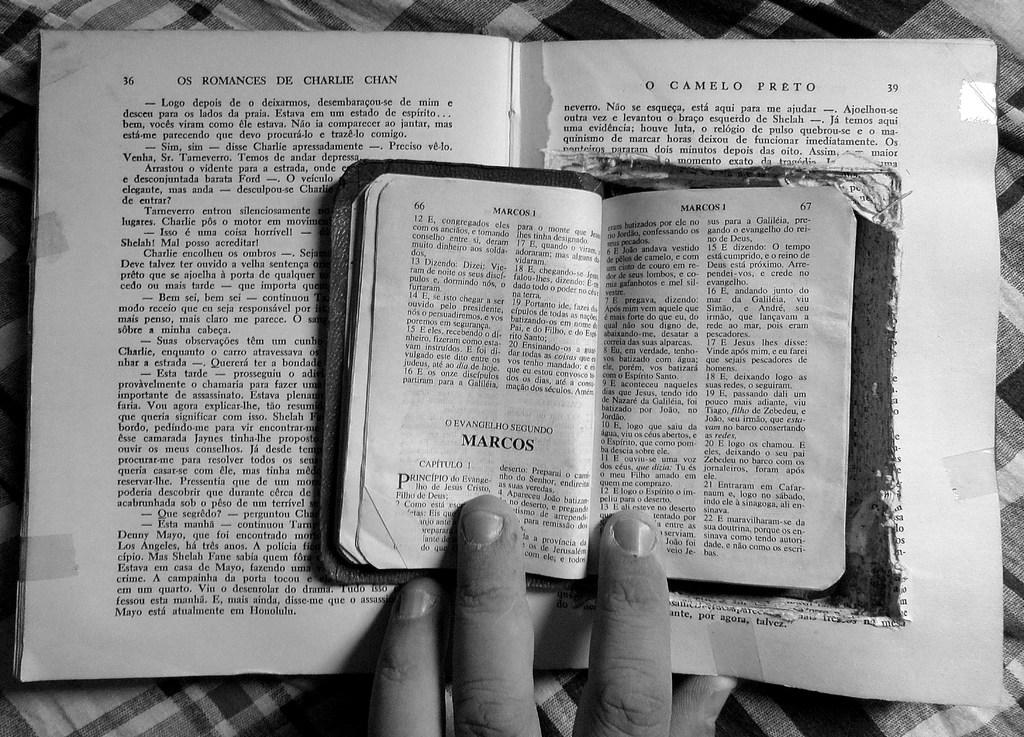<image>
Summarize the visual content of the image. A small and larger book, the small book is titled Marcos 1 and the larger is Romances de Charlie Chan. 